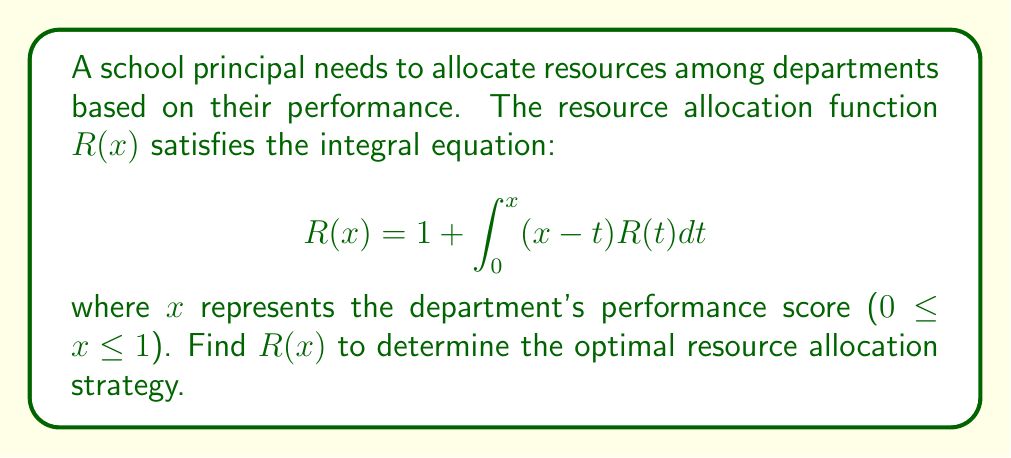Give your solution to this math problem. 1) This is a Volterra integral equation of the second kind. We can solve it using the method of successive approximations.

2) Let's start with $R_0(x) = 1$ as our initial approximation.

3) We then iterate using the formula:
   $$R_{n+1}(x) = 1 + \int_0^x (x-t)R_n(t)dt$$

4) For $n = 1$:
   $$R_1(x) = 1 + \int_0^x (x-t) \cdot 1 dt = 1 + [xt - \frac{t^2}{2}]_0^x = 1 + x^2 - \frac{x^2}{2} = 1 + \frac{x^2}{2}$$

5) For $n = 2$:
   $$R_2(x) = 1 + \int_0^x (x-t)(1 + \frac{t^2}{2})dt = 1 + [xt - \frac{t^2}{2} + \frac{xt^2}{2} - \frac{t^3}{6}]_0^x = 1 + \frac{x^2}{2} + \frac{x^3}{6}$$

6) For $n = 3$:
   $$R_3(x) = 1 + \int_0^x (x-t)(1 + \frac{t^2}{2} + \frac{t^3}{6})dt = 1 + \frac{x^2}{2} + \frac{x^3}{6} + \frac{x^4}{24}$$

7) We can observe a pattern forming. The general solution appears to be:
   $$R(x) = 1 + \frac{x^2}{2!} + \frac{x^3}{3!} + \frac{x^4}{4!} + ...$$

8) This series can be recognized as the Taylor series for $e^x$, excluding the linear term.

9) Therefore, the solution is:
   $$R(x) = e^x - x$$
Answer: $R(x) = e^x - x$ 